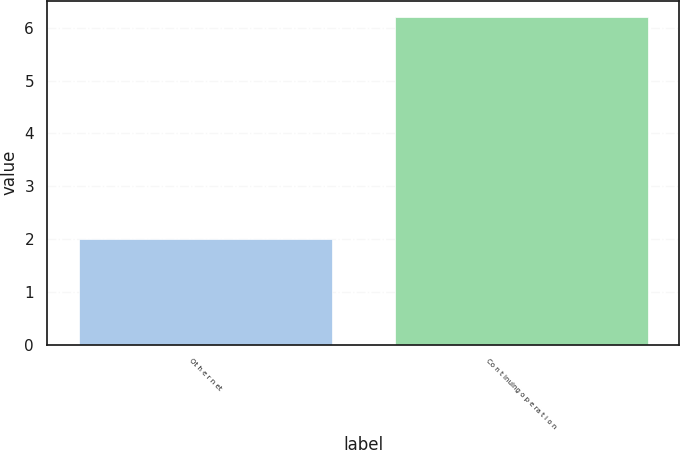Convert chart. <chart><loc_0><loc_0><loc_500><loc_500><bar_chart><fcel>Ot h e r n et<fcel>Co n t inuing o p e ra t i o n<nl><fcel>2<fcel>6.2<nl></chart> 